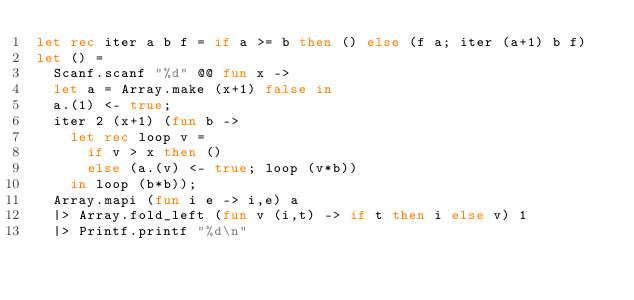<code> <loc_0><loc_0><loc_500><loc_500><_OCaml_>let rec iter a b f = if a >= b then () else (f a; iter (a+1) b f)
let () =
  Scanf.scanf "%d" @@ fun x ->
  let a = Array.make (x+1) false in
  a.(1) <- true;
  iter 2 (x+1) (fun b ->
    let rec loop v =
      if v > x then ()
      else (a.(v) <- true; loop (v*b))
    in loop (b*b));
  Array.mapi (fun i e -> i,e) a
  |> Array.fold_left (fun v (i,t) -> if t then i else v) 1
  |> Printf.printf "%d\n"</code> 